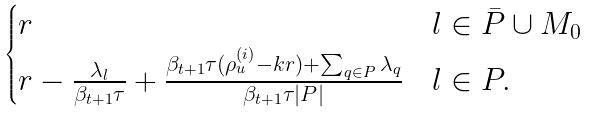Convert formula to latex. <formula><loc_0><loc_0><loc_500><loc_500>\begin{cases} r & l \in \bar { P } \cup M _ { 0 } \\ r - \frac { \lambda _ { l } } { \beta _ { t + 1 } \tau } + \frac { \beta _ { t + 1 } \tau ( \rho _ { u } ^ { ( i ) } - k r ) + \sum _ { q \in P } \lambda _ { q } } { \beta _ { t + 1 } \tau | P | } & l \in P . \end{cases}</formula> 